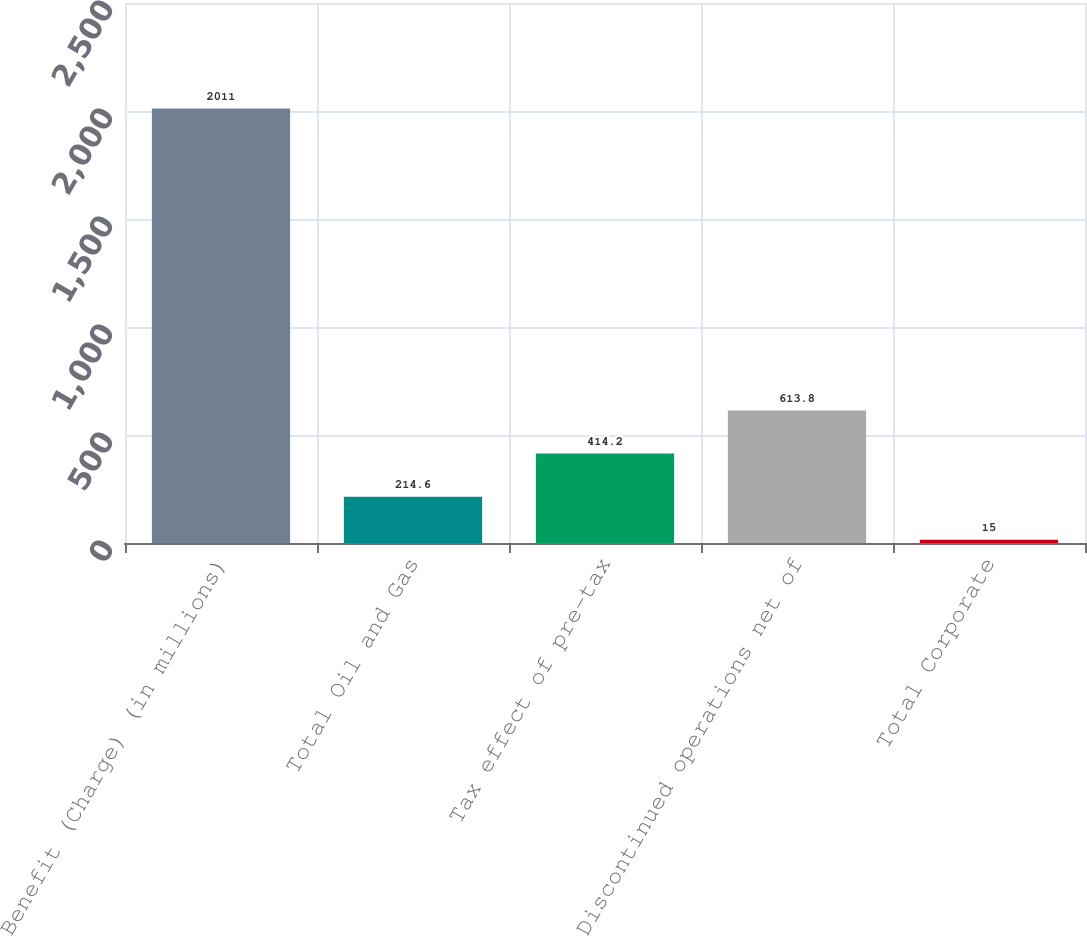<chart> <loc_0><loc_0><loc_500><loc_500><bar_chart><fcel>Benefit (Charge) (in millions)<fcel>Total Oil and Gas<fcel>Tax effect of pre-tax<fcel>Discontinued operations net of<fcel>Total Corporate<nl><fcel>2011<fcel>214.6<fcel>414.2<fcel>613.8<fcel>15<nl></chart> 